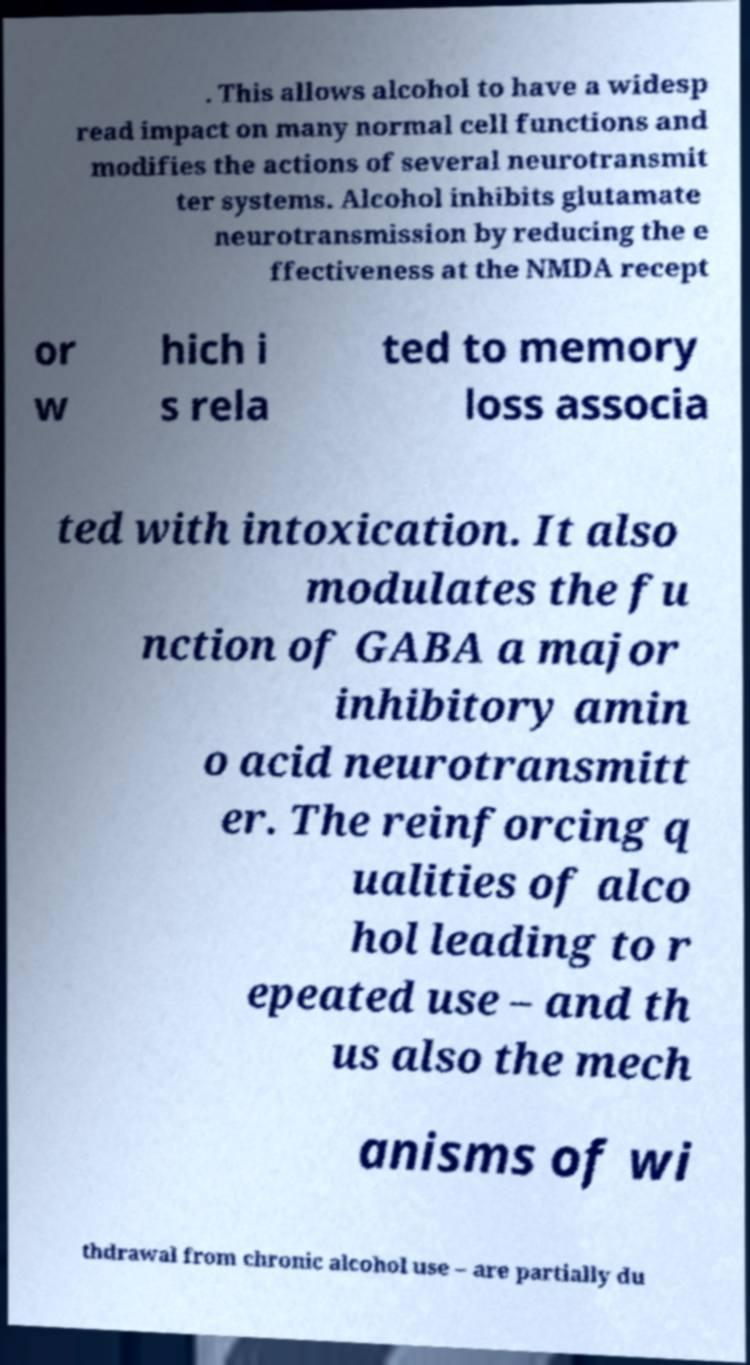What messages or text are displayed in this image? I need them in a readable, typed format. . This allows alcohol to have a widesp read impact on many normal cell functions and modifies the actions of several neurotransmit ter systems. Alcohol inhibits glutamate neurotransmission by reducing the e ffectiveness at the NMDA recept or w hich i s rela ted to memory loss associa ted with intoxication. It also modulates the fu nction of GABA a major inhibitory amin o acid neurotransmitt er. The reinforcing q ualities of alco hol leading to r epeated use – and th us also the mech anisms of wi thdrawal from chronic alcohol use – are partially du 